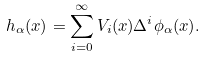<formula> <loc_0><loc_0><loc_500><loc_500>h _ { \alpha } ( x ) = \sum _ { i = 0 } ^ { \infty } V _ { i } ( x ) \Delta ^ { i } \phi _ { \alpha } ( x ) .</formula> 